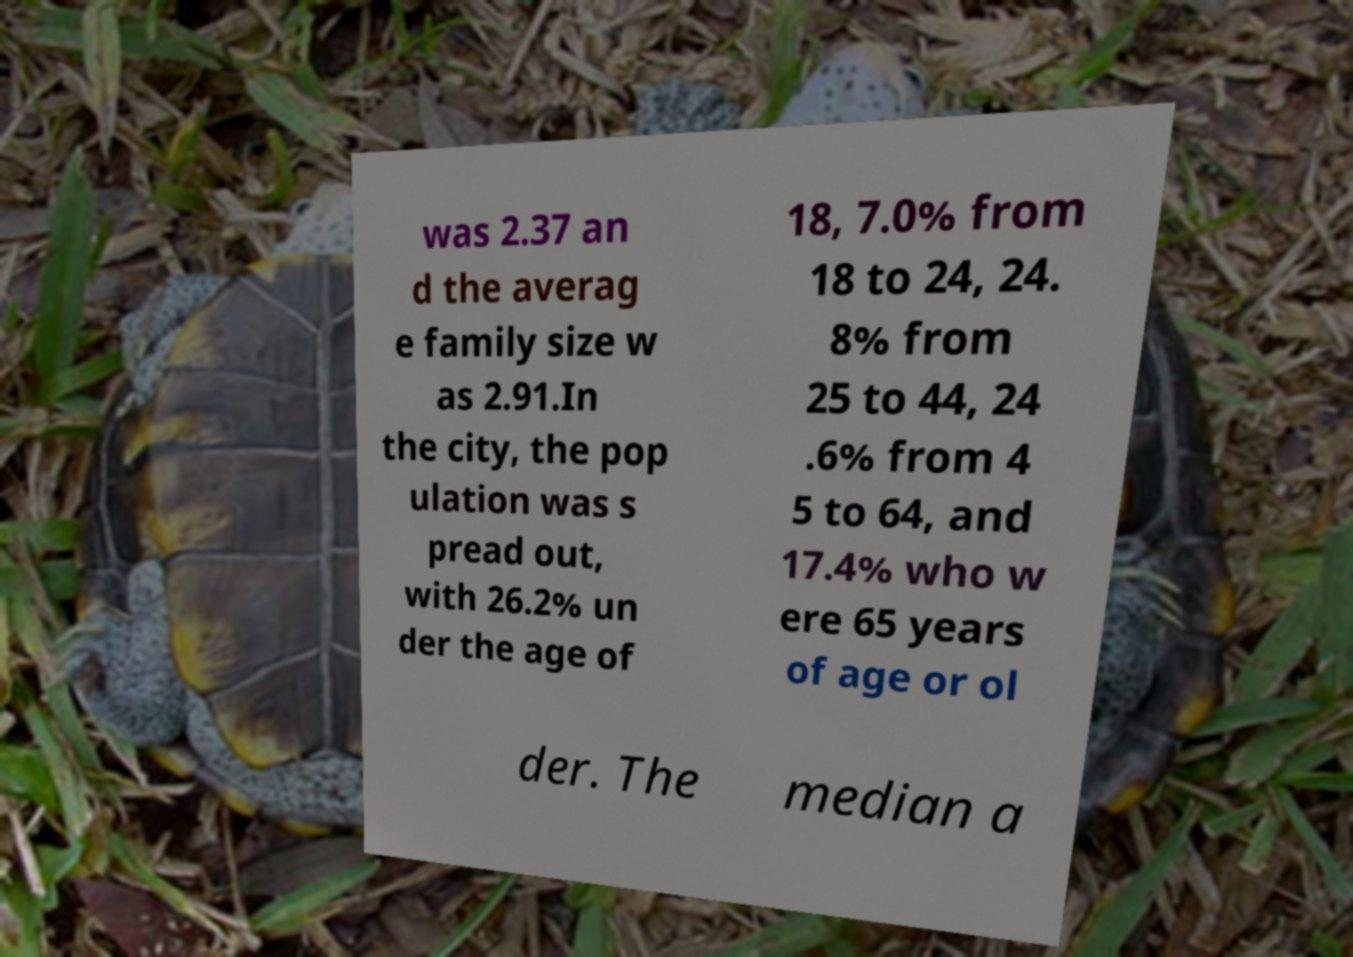Could you assist in decoding the text presented in this image and type it out clearly? was 2.37 an d the averag e family size w as 2.91.In the city, the pop ulation was s pread out, with 26.2% un der the age of 18, 7.0% from 18 to 24, 24. 8% from 25 to 44, 24 .6% from 4 5 to 64, and 17.4% who w ere 65 years of age or ol der. The median a 